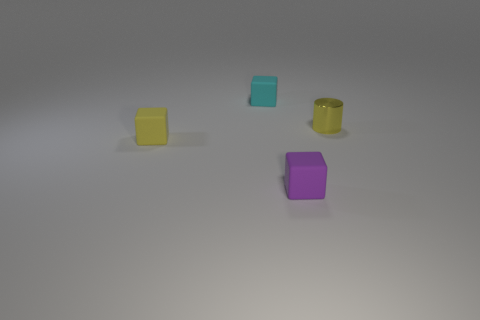Do the yellow object left of the small cyan rubber object and the purple block have the same material?
Provide a succinct answer. Yes. Is the number of yellow rubber objects that are in front of the small cylinder the same as the number of rubber things that are on the left side of the cyan thing?
Ensure brevity in your answer.  Yes. There is another tiny thing that is the same color as the metallic thing; what material is it?
Offer a terse response. Rubber. There is a small object behind the small metal cylinder; what number of purple rubber objects are on the left side of it?
Your answer should be very brief. 0. There is a small matte thing left of the cyan rubber object; does it have the same color as the tiny cube that is in front of the small yellow rubber thing?
Your response must be concise. No. What material is the yellow cube that is the same size as the yellow cylinder?
Provide a short and direct response. Rubber. There is a rubber thing behind the yellow object that is to the left of the tiny rubber block that is behind the yellow matte cube; what is its shape?
Offer a terse response. Cube. There is a metallic thing that is the same size as the purple rubber cube; what shape is it?
Your answer should be compact. Cylinder. There is a thing behind the small thing that is on the right side of the purple rubber block; how many yellow objects are left of it?
Your answer should be compact. 1. Are there more small blocks right of the cyan cube than tiny shiny things that are in front of the yellow cube?
Keep it short and to the point. Yes. 